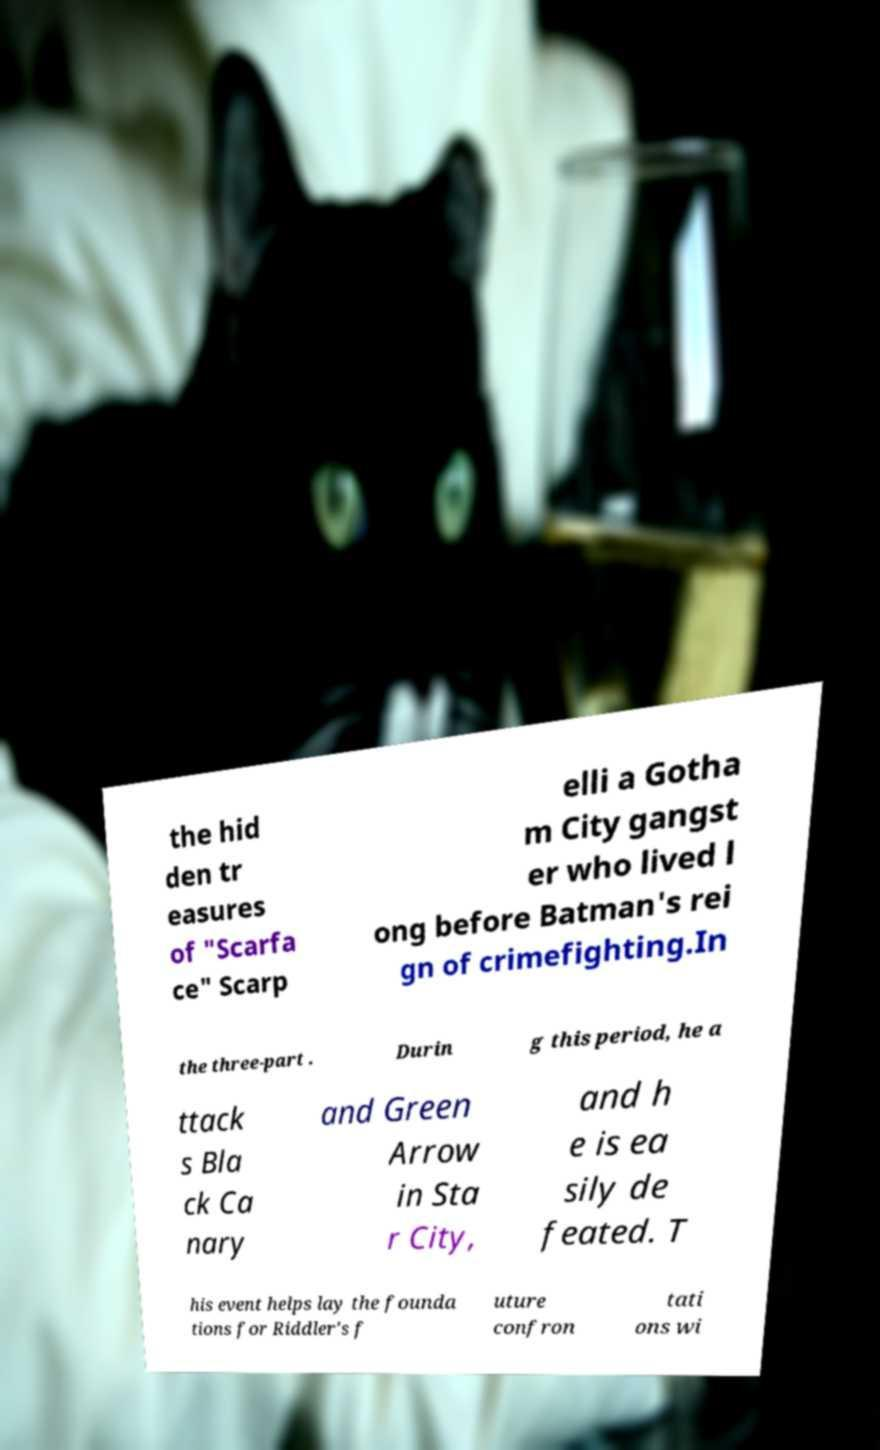I need the written content from this picture converted into text. Can you do that? the hid den tr easures of "Scarfa ce" Scarp elli a Gotha m City gangst er who lived l ong before Batman's rei gn of crimefighting.In the three-part . Durin g this period, he a ttack s Bla ck Ca nary and Green Arrow in Sta r City, and h e is ea sily de feated. T his event helps lay the founda tions for Riddler's f uture confron tati ons wi 